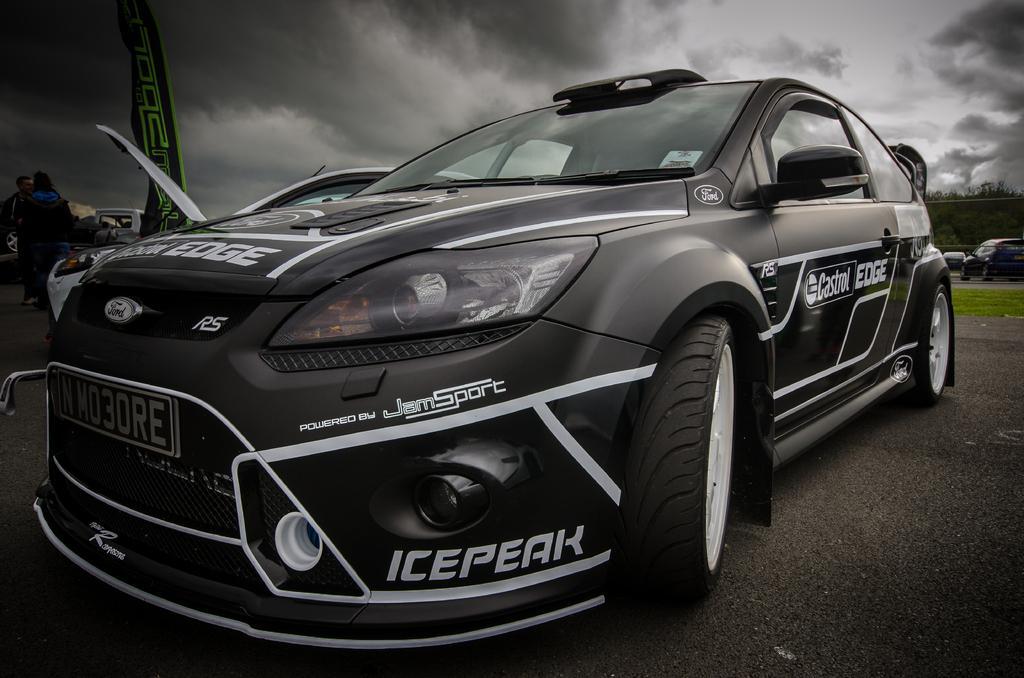How would you summarize this image in a sentence or two? In the foreground of this image, we see a car on the ground. In the background, there are grass, vehicles, trees, flag and few persons. On top, we the sky and the cloud. 